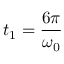Convert formula to latex. <formula><loc_0><loc_0><loc_500><loc_500>t _ { 1 } = \frac { 6 \pi } { \omega _ { 0 } }</formula> 